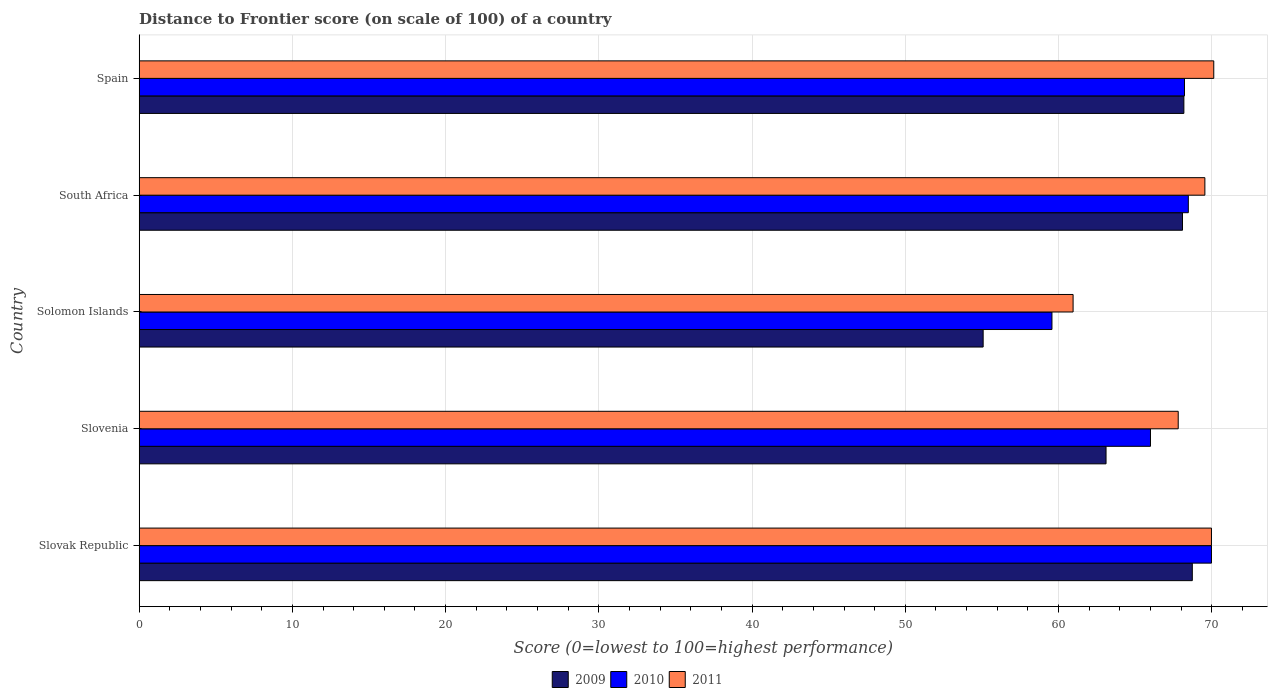How many groups of bars are there?
Offer a very short reply. 5. Are the number of bars per tick equal to the number of legend labels?
Offer a very short reply. Yes. Are the number of bars on each tick of the Y-axis equal?
Provide a succinct answer. Yes. How many bars are there on the 4th tick from the top?
Give a very brief answer. 3. What is the label of the 2nd group of bars from the top?
Ensure brevity in your answer.  South Africa. In how many cases, is the number of bars for a given country not equal to the number of legend labels?
Offer a terse response. 0. What is the distance to frontier score of in 2010 in Solomon Islands?
Your answer should be very brief. 59.57. Across all countries, what is the maximum distance to frontier score of in 2011?
Ensure brevity in your answer.  70.13. Across all countries, what is the minimum distance to frontier score of in 2011?
Offer a terse response. 60.95. In which country was the distance to frontier score of in 2009 maximum?
Keep it short and to the point. Slovak Republic. In which country was the distance to frontier score of in 2009 minimum?
Your answer should be very brief. Solomon Islands. What is the total distance to frontier score of in 2009 in the graph?
Provide a succinct answer. 323.18. What is the difference between the distance to frontier score of in 2009 in Solomon Islands and that in South Africa?
Provide a short and direct response. -13.01. What is the difference between the distance to frontier score of in 2010 in South Africa and the distance to frontier score of in 2009 in Slovenia?
Your answer should be compact. 5.37. What is the average distance to frontier score of in 2010 per country?
Provide a short and direct response. 66.45. What is the difference between the distance to frontier score of in 2011 and distance to frontier score of in 2009 in Slovenia?
Your response must be concise. 4.71. In how many countries, is the distance to frontier score of in 2009 greater than 36 ?
Offer a very short reply. 5. What is the ratio of the distance to frontier score of in 2011 in Slovenia to that in South Africa?
Your answer should be compact. 0.97. Is the difference between the distance to frontier score of in 2011 in Slovak Republic and South Africa greater than the difference between the distance to frontier score of in 2009 in Slovak Republic and South Africa?
Ensure brevity in your answer.  No. What is the difference between the highest and the second highest distance to frontier score of in 2010?
Your answer should be compact. 1.51. What is the difference between the highest and the lowest distance to frontier score of in 2011?
Your answer should be very brief. 9.18. Is it the case that in every country, the sum of the distance to frontier score of in 2010 and distance to frontier score of in 2011 is greater than the distance to frontier score of in 2009?
Provide a short and direct response. Yes. How many bars are there?
Ensure brevity in your answer.  15. Are all the bars in the graph horizontal?
Provide a short and direct response. Yes. How many countries are there in the graph?
Provide a succinct answer. 5. Are the values on the major ticks of X-axis written in scientific E-notation?
Offer a terse response. No. Does the graph contain grids?
Make the answer very short. Yes. How are the legend labels stacked?
Offer a terse response. Horizontal. What is the title of the graph?
Provide a succinct answer. Distance to Frontier score (on scale of 100) of a country. Does "1991" appear as one of the legend labels in the graph?
Keep it short and to the point. No. What is the label or title of the X-axis?
Your answer should be compact. Score (0=lowest to 100=highest performance). What is the label or title of the Y-axis?
Give a very brief answer. Country. What is the Score (0=lowest to 100=highest performance) of 2009 in Slovak Republic?
Your answer should be compact. 68.73. What is the Score (0=lowest to 100=highest performance) in 2010 in Slovak Republic?
Give a very brief answer. 69.98. What is the Score (0=lowest to 100=highest performance) in 2011 in Slovak Republic?
Keep it short and to the point. 69.98. What is the Score (0=lowest to 100=highest performance) in 2009 in Slovenia?
Provide a succinct answer. 63.1. What is the Score (0=lowest to 100=highest performance) in 2010 in Slovenia?
Your answer should be compact. 66. What is the Score (0=lowest to 100=highest performance) in 2011 in Slovenia?
Offer a terse response. 67.81. What is the Score (0=lowest to 100=highest performance) in 2009 in Solomon Islands?
Give a very brief answer. 55.08. What is the Score (0=lowest to 100=highest performance) in 2010 in Solomon Islands?
Offer a very short reply. 59.57. What is the Score (0=lowest to 100=highest performance) in 2011 in Solomon Islands?
Provide a succinct answer. 60.95. What is the Score (0=lowest to 100=highest performance) in 2009 in South Africa?
Your answer should be compact. 68.09. What is the Score (0=lowest to 100=highest performance) in 2010 in South Africa?
Keep it short and to the point. 68.47. What is the Score (0=lowest to 100=highest performance) in 2011 in South Africa?
Give a very brief answer. 69.55. What is the Score (0=lowest to 100=highest performance) in 2009 in Spain?
Offer a terse response. 68.18. What is the Score (0=lowest to 100=highest performance) in 2010 in Spain?
Your response must be concise. 68.22. What is the Score (0=lowest to 100=highest performance) of 2011 in Spain?
Provide a succinct answer. 70.13. Across all countries, what is the maximum Score (0=lowest to 100=highest performance) in 2009?
Offer a very short reply. 68.73. Across all countries, what is the maximum Score (0=lowest to 100=highest performance) in 2010?
Make the answer very short. 69.98. Across all countries, what is the maximum Score (0=lowest to 100=highest performance) of 2011?
Your answer should be compact. 70.13. Across all countries, what is the minimum Score (0=lowest to 100=highest performance) in 2009?
Keep it short and to the point. 55.08. Across all countries, what is the minimum Score (0=lowest to 100=highest performance) of 2010?
Provide a succinct answer. 59.57. Across all countries, what is the minimum Score (0=lowest to 100=highest performance) of 2011?
Keep it short and to the point. 60.95. What is the total Score (0=lowest to 100=highest performance) in 2009 in the graph?
Keep it short and to the point. 323.18. What is the total Score (0=lowest to 100=highest performance) of 2010 in the graph?
Provide a succinct answer. 332.24. What is the total Score (0=lowest to 100=highest performance) of 2011 in the graph?
Ensure brevity in your answer.  338.42. What is the difference between the Score (0=lowest to 100=highest performance) in 2009 in Slovak Republic and that in Slovenia?
Offer a terse response. 5.63. What is the difference between the Score (0=lowest to 100=highest performance) in 2010 in Slovak Republic and that in Slovenia?
Keep it short and to the point. 3.98. What is the difference between the Score (0=lowest to 100=highest performance) of 2011 in Slovak Republic and that in Slovenia?
Your answer should be compact. 2.17. What is the difference between the Score (0=lowest to 100=highest performance) in 2009 in Slovak Republic and that in Solomon Islands?
Your answer should be compact. 13.65. What is the difference between the Score (0=lowest to 100=highest performance) in 2010 in Slovak Republic and that in Solomon Islands?
Offer a very short reply. 10.41. What is the difference between the Score (0=lowest to 100=highest performance) of 2011 in Slovak Republic and that in Solomon Islands?
Keep it short and to the point. 9.03. What is the difference between the Score (0=lowest to 100=highest performance) in 2009 in Slovak Republic and that in South Africa?
Your answer should be compact. 0.64. What is the difference between the Score (0=lowest to 100=highest performance) in 2010 in Slovak Republic and that in South Africa?
Offer a terse response. 1.51. What is the difference between the Score (0=lowest to 100=highest performance) of 2011 in Slovak Republic and that in South Africa?
Provide a short and direct response. 0.43. What is the difference between the Score (0=lowest to 100=highest performance) of 2009 in Slovak Republic and that in Spain?
Keep it short and to the point. 0.55. What is the difference between the Score (0=lowest to 100=highest performance) in 2010 in Slovak Republic and that in Spain?
Provide a short and direct response. 1.76. What is the difference between the Score (0=lowest to 100=highest performance) of 2009 in Slovenia and that in Solomon Islands?
Your answer should be compact. 8.02. What is the difference between the Score (0=lowest to 100=highest performance) of 2010 in Slovenia and that in Solomon Islands?
Your response must be concise. 6.43. What is the difference between the Score (0=lowest to 100=highest performance) of 2011 in Slovenia and that in Solomon Islands?
Keep it short and to the point. 6.86. What is the difference between the Score (0=lowest to 100=highest performance) in 2009 in Slovenia and that in South Africa?
Offer a terse response. -4.99. What is the difference between the Score (0=lowest to 100=highest performance) of 2010 in Slovenia and that in South Africa?
Offer a very short reply. -2.47. What is the difference between the Score (0=lowest to 100=highest performance) in 2011 in Slovenia and that in South Africa?
Make the answer very short. -1.74. What is the difference between the Score (0=lowest to 100=highest performance) of 2009 in Slovenia and that in Spain?
Ensure brevity in your answer.  -5.08. What is the difference between the Score (0=lowest to 100=highest performance) of 2010 in Slovenia and that in Spain?
Ensure brevity in your answer.  -2.22. What is the difference between the Score (0=lowest to 100=highest performance) of 2011 in Slovenia and that in Spain?
Provide a succinct answer. -2.32. What is the difference between the Score (0=lowest to 100=highest performance) in 2009 in Solomon Islands and that in South Africa?
Offer a very short reply. -13.01. What is the difference between the Score (0=lowest to 100=highest performance) in 2010 in Solomon Islands and that in South Africa?
Keep it short and to the point. -8.9. What is the difference between the Score (0=lowest to 100=highest performance) of 2011 in Solomon Islands and that in South Africa?
Offer a terse response. -8.6. What is the difference between the Score (0=lowest to 100=highest performance) in 2010 in Solomon Islands and that in Spain?
Give a very brief answer. -8.65. What is the difference between the Score (0=lowest to 100=highest performance) in 2011 in Solomon Islands and that in Spain?
Offer a terse response. -9.18. What is the difference between the Score (0=lowest to 100=highest performance) of 2009 in South Africa and that in Spain?
Offer a very short reply. -0.09. What is the difference between the Score (0=lowest to 100=highest performance) of 2010 in South Africa and that in Spain?
Make the answer very short. 0.25. What is the difference between the Score (0=lowest to 100=highest performance) in 2011 in South Africa and that in Spain?
Offer a terse response. -0.58. What is the difference between the Score (0=lowest to 100=highest performance) in 2009 in Slovak Republic and the Score (0=lowest to 100=highest performance) in 2010 in Slovenia?
Your answer should be compact. 2.73. What is the difference between the Score (0=lowest to 100=highest performance) of 2010 in Slovak Republic and the Score (0=lowest to 100=highest performance) of 2011 in Slovenia?
Your answer should be compact. 2.17. What is the difference between the Score (0=lowest to 100=highest performance) in 2009 in Slovak Republic and the Score (0=lowest to 100=highest performance) in 2010 in Solomon Islands?
Make the answer very short. 9.16. What is the difference between the Score (0=lowest to 100=highest performance) in 2009 in Slovak Republic and the Score (0=lowest to 100=highest performance) in 2011 in Solomon Islands?
Make the answer very short. 7.78. What is the difference between the Score (0=lowest to 100=highest performance) of 2010 in Slovak Republic and the Score (0=lowest to 100=highest performance) of 2011 in Solomon Islands?
Give a very brief answer. 9.03. What is the difference between the Score (0=lowest to 100=highest performance) in 2009 in Slovak Republic and the Score (0=lowest to 100=highest performance) in 2010 in South Africa?
Offer a very short reply. 0.26. What is the difference between the Score (0=lowest to 100=highest performance) of 2009 in Slovak Republic and the Score (0=lowest to 100=highest performance) of 2011 in South Africa?
Keep it short and to the point. -0.82. What is the difference between the Score (0=lowest to 100=highest performance) in 2010 in Slovak Republic and the Score (0=lowest to 100=highest performance) in 2011 in South Africa?
Your answer should be very brief. 0.43. What is the difference between the Score (0=lowest to 100=highest performance) of 2009 in Slovak Republic and the Score (0=lowest to 100=highest performance) of 2010 in Spain?
Ensure brevity in your answer.  0.51. What is the difference between the Score (0=lowest to 100=highest performance) of 2010 in Slovak Republic and the Score (0=lowest to 100=highest performance) of 2011 in Spain?
Your answer should be very brief. -0.15. What is the difference between the Score (0=lowest to 100=highest performance) in 2009 in Slovenia and the Score (0=lowest to 100=highest performance) in 2010 in Solomon Islands?
Offer a very short reply. 3.53. What is the difference between the Score (0=lowest to 100=highest performance) of 2009 in Slovenia and the Score (0=lowest to 100=highest performance) of 2011 in Solomon Islands?
Provide a succinct answer. 2.15. What is the difference between the Score (0=lowest to 100=highest performance) of 2010 in Slovenia and the Score (0=lowest to 100=highest performance) of 2011 in Solomon Islands?
Provide a short and direct response. 5.05. What is the difference between the Score (0=lowest to 100=highest performance) of 2009 in Slovenia and the Score (0=lowest to 100=highest performance) of 2010 in South Africa?
Provide a succinct answer. -5.37. What is the difference between the Score (0=lowest to 100=highest performance) in 2009 in Slovenia and the Score (0=lowest to 100=highest performance) in 2011 in South Africa?
Your answer should be very brief. -6.45. What is the difference between the Score (0=lowest to 100=highest performance) in 2010 in Slovenia and the Score (0=lowest to 100=highest performance) in 2011 in South Africa?
Provide a succinct answer. -3.55. What is the difference between the Score (0=lowest to 100=highest performance) of 2009 in Slovenia and the Score (0=lowest to 100=highest performance) of 2010 in Spain?
Your response must be concise. -5.12. What is the difference between the Score (0=lowest to 100=highest performance) of 2009 in Slovenia and the Score (0=lowest to 100=highest performance) of 2011 in Spain?
Provide a short and direct response. -7.03. What is the difference between the Score (0=lowest to 100=highest performance) in 2010 in Slovenia and the Score (0=lowest to 100=highest performance) in 2011 in Spain?
Provide a succinct answer. -4.13. What is the difference between the Score (0=lowest to 100=highest performance) in 2009 in Solomon Islands and the Score (0=lowest to 100=highest performance) in 2010 in South Africa?
Ensure brevity in your answer.  -13.39. What is the difference between the Score (0=lowest to 100=highest performance) in 2009 in Solomon Islands and the Score (0=lowest to 100=highest performance) in 2011 in South Africa?
Your answer should be very brief. -14.47. What is the difference between the Score (0=lowest to 100=highest performance) in 2010 in Solomon Islands and the Score (0=lowest to 100=highest performance) in 2011 in South Africa?
Your answer should be very brief. -9.98. What is the difference between the Score (0=lowest to 100=highest performance) of 2009 in Solomon Islands and the Score (0=lowest to 100=highest performance) of 2010 in Spain?
Make the answer very short. -13.14. What is the difference between the Score (0=lowest to 100=highest performance) of 2009 in Solomon Islands and the Score (0=lowest to 100=highest performance) of 2011 in Spain?
Offer a terse response. -15.05. What is the difference between the Score (0=lowest to 100=highest performance) in 2010 in Solomon Islands and the Score (0=lowest to 100=highest performance) in 2011 in Spain?
Provide a succinct answer. -10.56. What is the difference between the Score (0=lowest to 100=highest performance) in 2009 in South Africa and the Score (0=lowest to 100=highest performance) in 2010 in Spain?
Ensure brevity in your answer.  -0.13. What is the difference between the Score (0=lowest to 100=highest performance) in 2009 in South Africa and the Score (0=lowest to 100=highest performance) in 2011 in Spain?
Your answer should be compact. -2.04. What is the difference between the Score (0=lowest to 100=highest performance) of 2010 in South Africa and the Score (0=lowest to 100=highest performance) of 2011 in Spain?
Provide a succinct answer. -1.66. What is the average Score (0=lowest to 100=highest performance) of 2009 per country?
Offer a terse response. 64.64. What is the average Score (0=lowest to 100=highest performance) in 2010 per country?
Give a very brief answer. 66.45. What is the average Score (0=lowest to 100=highest performance) of 2011 per country?
Offer a very short reply. 67.68. What is the difference between the Score (0=lowest to 100=highest performance) in 2009 and Score (0=lowest to 100=highest performance) in 2010 in Slovak Republic?
Offer a terse response. -1.25. What is the difference between the Score (0=lowest to 100=highest performance) in 2009 and Score (0=lowest to 100=highest performance) in 2011 in Slovak Republic?
Keep it short and to the point. -1.25. What is the difference between the Score (0=lowest to 100=highest performance) of 2009 and Score (0=lowest to 100=highest performance) of 2010 in Slovenia?
Your answer should be very brief. -2.9. What is the difference between the Score (0=lowest to 100=highest performance) in 2009 and Score (0=lowest to 100=highest performance) in 2011 in Slovenia?
Your response must be concise. -4.71. What is the difference between the Score (0=lowest to 100=highest performance) in 2010 and Score (0=lowest to 100=highest performance) in 2011 in Slovenia?
Give a very brief answer. -1.81. What is the difference between the Score (0=lowest to 100=highest performance) in 2009 and Score (0=lowest to 100=highest performance) in 2010 in Solomon Islands?
Give a very brief answer. -4.49. What is the difference between the Score (0=lowest to 100=highest performance) in 2009 and Score (0=lowest to 100=highest performance) in 2011 in Solomon Islands?
Your response must be concise. -5.87. What is the difference between the Score (0=lowest to 100=highest performance) of 2010 and Score (0=lowest to 100=highest performance) of 2011 in Solomon Islands?
Ensure brevity in your answer.  -1.38. What is the difference between the Score (0=lowest to 100=highest performance) of 2009 and Score (0=lowest to 100=highest performance) of 2010 in South Africa?
Give a very brief answer. -0.38. What is the difference between the Score (0=lowest to 100=highest performance) of 2009 and Score (0=lowest to 100=highest performance) of 2011 in South Africa?
Ensure brevity in your answer.  -1.46. What is the difference between the Score (0=lowest to 100=highest performance) of 2010 and Score (0=lowest to 100=highest performance) of 2011 in South Africa?
Ensure brevity in your answer.  -1.08. What is the difference between the Score (0=lowest to 100=highest performance) in 2009 and Score (0=lowest to 100=highest performance) in 2010 in Spain?
Make the answer very short. -0.04. What is the difference between the Score (0=lowest to 100=highest performance) of 2009 and Score (0=lowest to 100=highest performance) of 2011 in Spain?
Give a very brief answer. -1.95. What is the difference between the Score (0=lowest to 100=highest performance) of 2010 and Score (0=lowest to 100=highest performance) of 2011 in Spain?
Keep it short and to the point. -1.91. What is the ratio of the Score (0=lowest to 100=highest performance) of 2009 in Slovak Republic to that in Slovenia?
Provide a succinct answer. 1.09. What is the ratio of the Score (0=lowest to 100=highest performance) in 2010 in Slovak Republic to that in Slovenia?
Offer a terse response. 1.06. What is the ratio of the Score (0=lowest to 100=highest performance) in 2011 in Slovak Republic to that in Slovenia?
Your answer should be compact. 1.03. What is the ratio of the Score (0=lowest to 100=highest performance) of 2009 in Slovak Republic to that in Solomon Islands?
Your answer should be compact. 1.25. What is the ratio of the Score (0=lowest to 100=highest performance) of 2010 in Slovak Republic to that in Solomon Islands?
Provide a short and direct response. 1.17. What is the ratio of the Score (0=lowest to 100=highest performance) of 2011 in Slovak Republic to that in Solomon Islands?
Keep it short and to the point. 1.15. What is the ratio of the Score (0=lowest to 100=highest performance) of 2009 in Slovak Republic to that in South Africa?
Provide a short and direct response. 1.01. What is the ratio of the Score (0=lowest to 100=highest performance) in 2010 in Slovak Republic to that in South Africa?
Provide a succinct answer. 1.02. What is the ratio of the Score (0=lowest to 100=highest performance) of 2009 in Slovak Republic to that in Spain?
Your answer should be compact. 1.01. What is the ratio of the Score (0=lowest to 100=highest performance) of 2010 in Slovak Republic to that in Spain?
Provide a succinct answer. 1.03. What is the ratio of the Score (0=lowest to 100=highest performance) of 2011 in Slovak Republic to that in Spain?
Offer a terse response. 1. What is the ratio of the Score (0=lowest to 100=highest performance) of 2009 in Slovenia to that in Solomon Islands?
Your response must be concise. 1.15. What is the ratio of the Score (0=lowest to 100=highest performance) in 2010 in Slovenia to that in Solomon Islands?
Your answer should be compact. 1.11. What is the ratio of the Score (0=lowest to 100=highest performance) of 2011 in Slovenia to that in Solomon Islands?
Your answer should be very brief. 1.11. What is the ratio of the Score (0=lowest to 100=highest performance) of 2009 in Slovenia to that in South Africa?
Your response must be concise. 0.93. What is the ratio of the Score (0=lowest to 100=highest performance) in 2010 in Slovenia to that in South Africa?
Offer a very short reply. 0.96. What is the ratio of the Score (0=lowest to 100=highest performance) in 2011 in Slovenia to that in South Africa?
Your answer should be compact. 0.97. What is the ratio of the Score (0=lowest to 100=highest performance) in 2009 in Slovenia to that in Spain?
Provide a short and direct response. 0.93. What is the ratio of the Score (0=lowest to 100=highest performance) of 2010 in Slovenia to that in Spain?
Give a very brief answer. 0.97. What is the ratio of the Score (0=lowest to 100=highest performance) in 2011 in Slovenia to that in Spain?
Keep it short and to the point. 0.97. What is the ratio of the Score (0=lowest to 100=highest performance) of 2009 in Solomon Islands to that in South Africa?
Your response must be concise. 0.81. What is the ratio of the Score (0=lowest to 100=highest performance) of 2010 in Solomon Islands to that in South Africa?
Your answer should be compact. 0.87. What is the ratio of the Score (0=lowest to 100=highest performance) of 2011 in Solomon Islands to that in South Africa?
Offer a terse response. 0.88. What is the ratio of the Score (0=lowest to 100=highest performance) in 2009 in Solomon Islands to that in Spain?
Keep it short and to the point. 0.81. What is the ratio of the Score (0=lowest to 100=highest performance) in 2010 in Solomon Islands to that in Spain?
Make the answer very short. 0.87. What is the ratio of the Score (0=lowest to 100=highest performance) of 2011 in Solomon Islands to that in Spain?
Offer a terse response. 0.87. What is the ratio of the Score (0=lowest to 100=highest performance) in 2011 in South Africa to that in Spain?
Give a very brief answer. 0.99. What is the difference between the highest and the second highest Score (0=lowest to 100=highest performance) of 2009?
Provide a succinct answer. 0.55. What is the difference between the highest and the second highest Score (0=lowest to 100=highest performance) of 2010?
Ensure brevity in your answer.  1.51. What is the difference between the highest and the second highest Score (0=lowest to 100=highest performance) of 2011?
Offer a very short reply. 0.15. What is the difference between the highest and the lowest Score (0=lowest to 100=highest performance) in 2009?
Your answer should be compact. 13.65. What is the difference between the highest and the lowest Score (0=lowest to 100=highest performance) in 2010?
Your response must be concise. 10.41. What is the difference between the highest and the lowest Score (0=lowest to 100=highest performance) of 2011?
Provide a short and direct response. 9.18. 